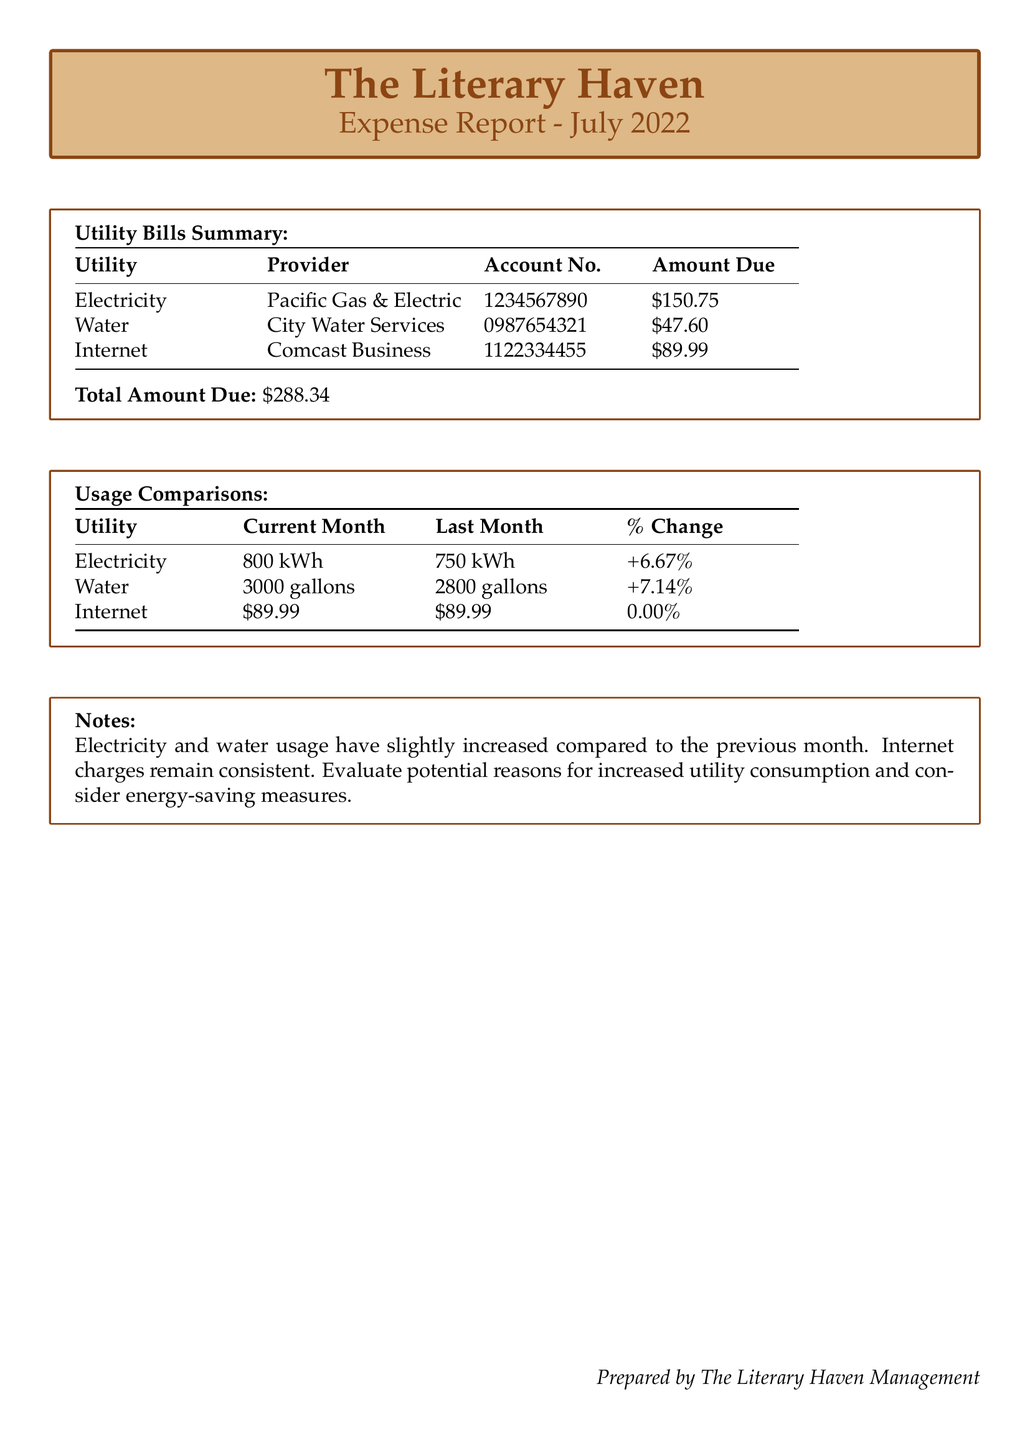what is the total amount due? The total amount due is calculated by adding all the individual utility amounts listed in the document.
Answer: $288.34 who is the provider for electricity? The document specifies the provider for electricity mentioned in the Utility Bills Summary.
Answer: Pacific Gas & Electric how many gallons of water were used this month? The current month's water usage is explicitly stated in the Usage Comparisons section of the report.
Answer: 3000 gallons what was the percentage change in electricity usage? The percentage change for electricity usage is provided in the Usage Comparisons section, comparing the current and last month's usage.
Answer: +6.67% which utility remains consistent in charges? The Usage Comparisons section shows that the charges for this utility did not change compared to the previous month.
Answer: Internet what is the account number for water services? The document lists the specific account number for water services in the Utility Bills Summary.
Answer: 0987654321 what is the percentage change in water usage? This information is provided in the Usage Comparisons table, showing changes from the previous month.
Answer: +7.14% which utility has the highest amount due? The total amounts due for each utility are compared in the Utility Bills Summary to find the highest.
Answer: Electricity what note is provided regarding utility consumption? The notes section provides insight into the situation concerning electricity and water usage changes.
Answer: Increased utility consumption and consider energy-saving measures 